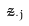<formula> <loc_0><loc_0><loc_500><loc_500>\tilde { z } _ { \cdot j }</formula> 